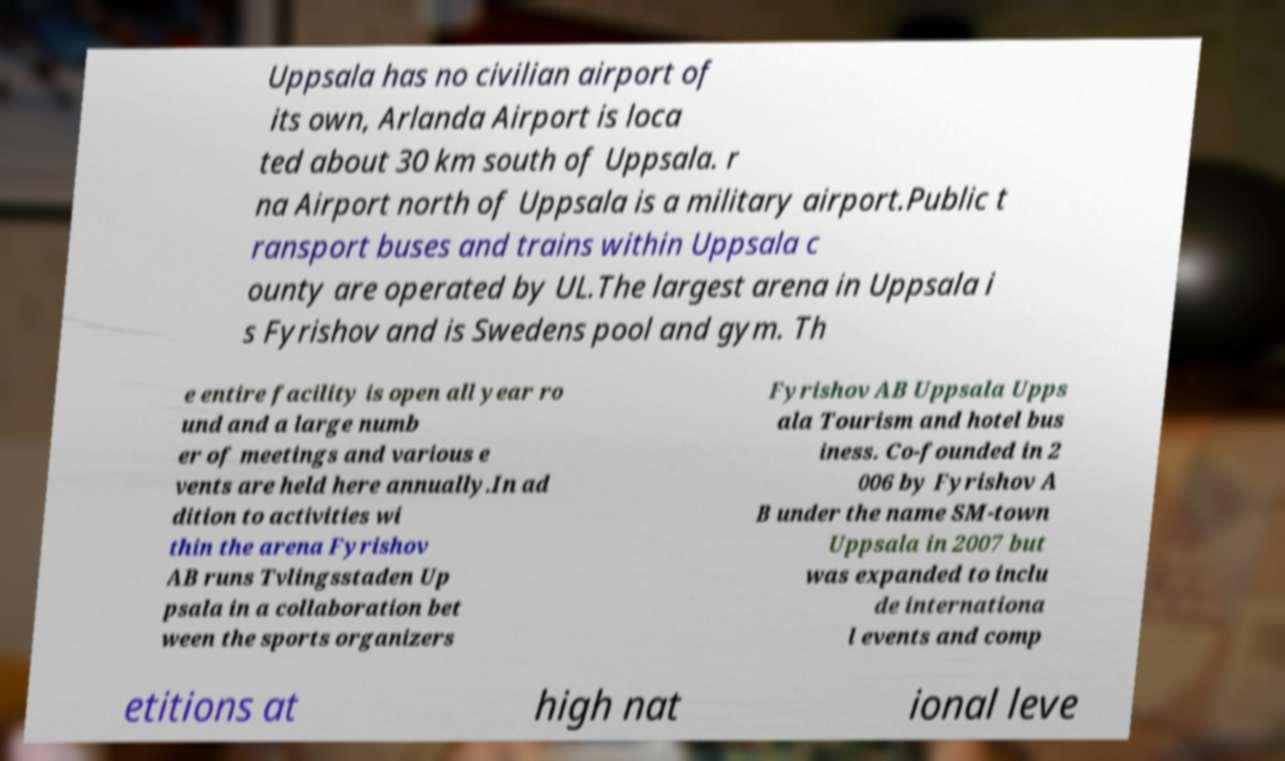I need the written content from this picture converted into text. Can you do that? Uppsala has no civilian airport of its own, Arlanda Airport is loca ted about 30 km south of Uppsala. r na Airport north of Uppsala is a military airport.Public t ransport buses and trains within Uppsala c ounty are operated by UL.The largest arena in Uppsala i s Fyrishov and is Swedens pool and gym. Th e entire facility is open all year ro und and a large numb er of meetings and various e vents are held here annually.In ad dition to activities wi thin the arena Fyrishov AB runs Tvlingsstaden Up psala in a collaboration bet ween the sports organizers Fyrishov AB Uppsala Upps ala Tourism and hotel bus iness. Co-founded in 2 006 by Fyrishov A B under the name SM-town Uppsala in 2007 but was expanded to inclu de internationa l events and comp etitions at high nat ional leve 